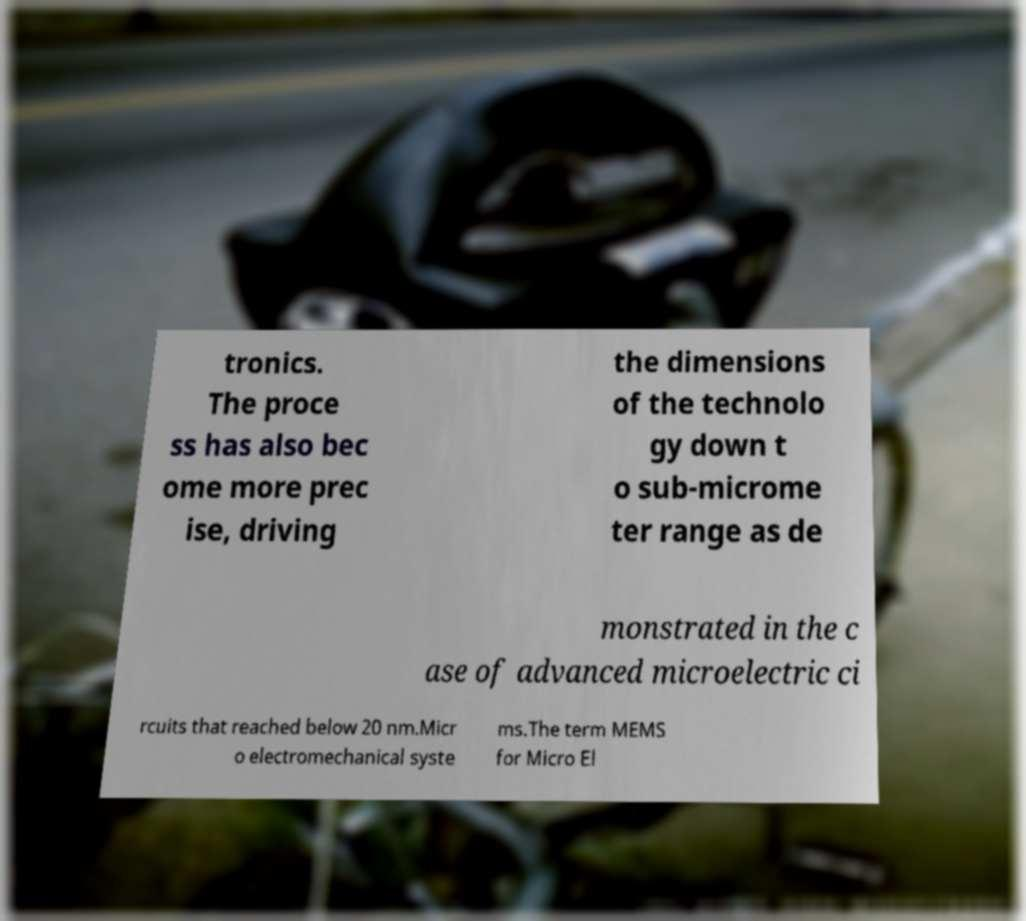Could you assist in decoding the text presented in this image and type it out clearly? tronics. The proce ss has also bec ome more prec ise, driving the dimensions of the technolo gy down t o sub-microme ter range as de monstrated in the c ase of advanced microelectric ci rcuits that reached below 20 nm.Micr o electromechanical syste ms.The term MEMS for Micro El 